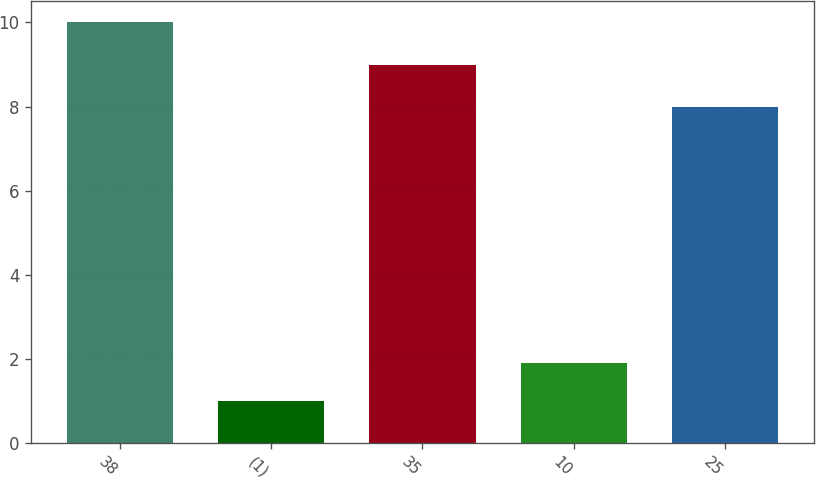Convert chart. <chart><loc_0><loc_0><loc_500><loc_500><bar_chart><fcel>38<fcel>(1)<fcel>35<fcel>10<fcel>25<nl><fcel>10<fcel>1<fcel>9<fcel>1.9<fcel>8<nl></chart> 